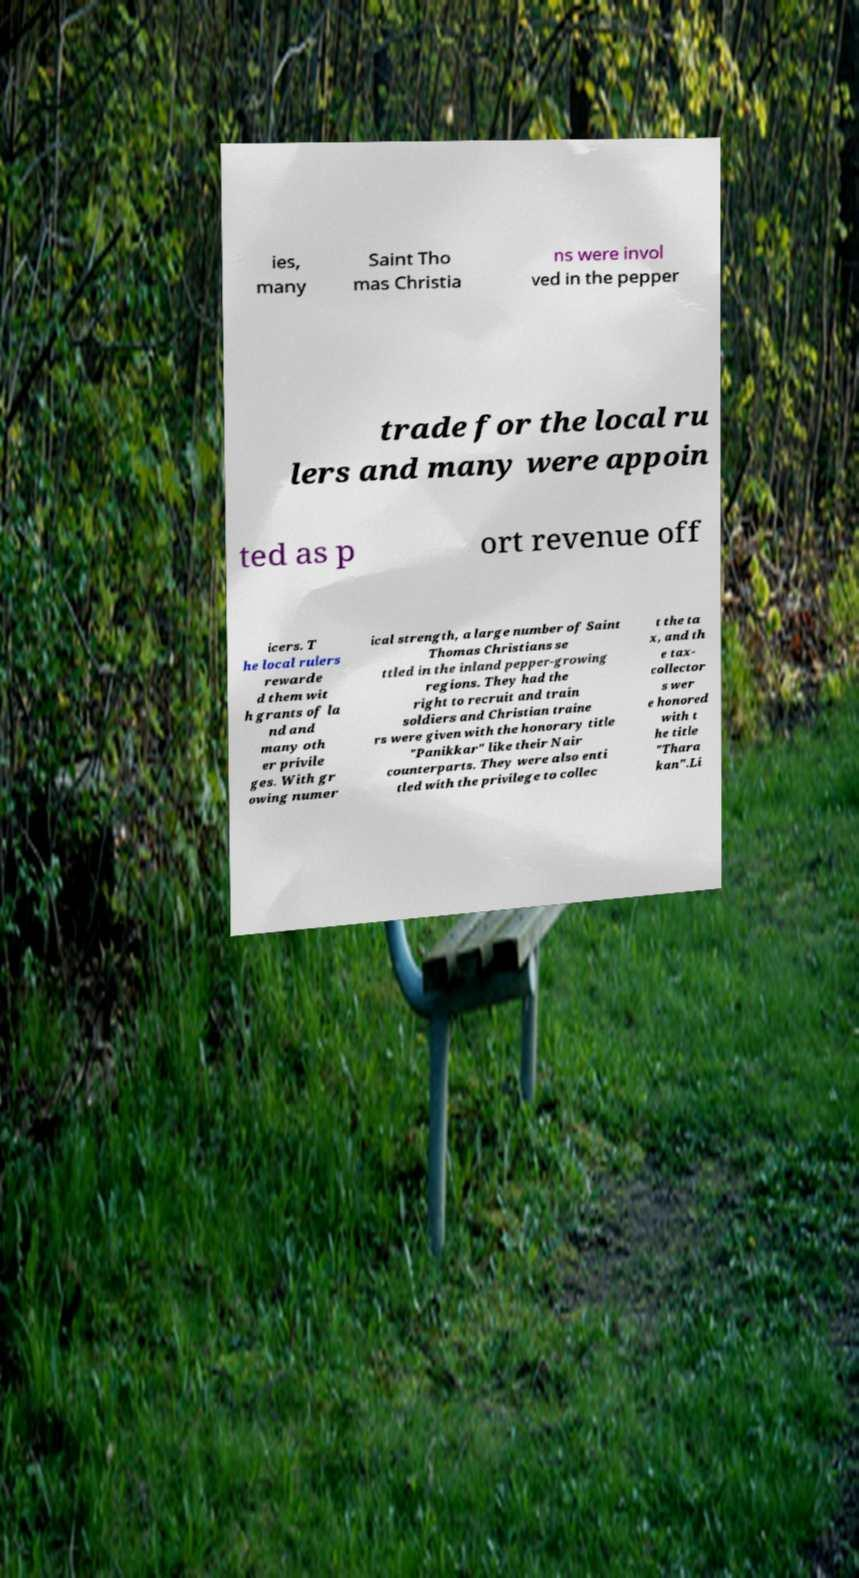I need the written content from this picture converted into text. Can you do that? ies, many Saint Tho mas Christia ns were invol ved in the pepper trade for the local ru lers and many were appoin ted as p ort revenue off icers. T he local rulers rewarde d them wit h grants of la nd and many oth er privile ges. With gr owing numer ical strength, a large number of Saint Thomas Christians se ttled in the inland pepper-growing regions. They had the right to recruit and train soldiers and Christian traine rs were given with the honorary title "Panikkar" like their Nair counterparts. They were also enti tled with the privilege to collec t the ta x, and th e tax- collector s wer e honored with t he title "Thara kan".Li 